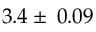Convert formula to latex. <formula><loc_0><loc_0><loc_500><loc_500>3 . 4 \pm \, 0 . 0 9</formula> 